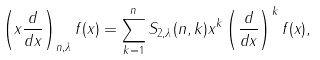Convert formula to latex. <formula><loc_0><loc_0><loc_500><loc_500>\left ( x \frac { d } { d x } \right ) _ { n , \lambda } f ( x ) = \sum _ { k = 1 } ^ { n } S _ { 2 , \lambda } ( n , k ) x ^ { k } \left ( \frac { d } { d x } \right ) ^ { k } f ( x ) ,</formula> 